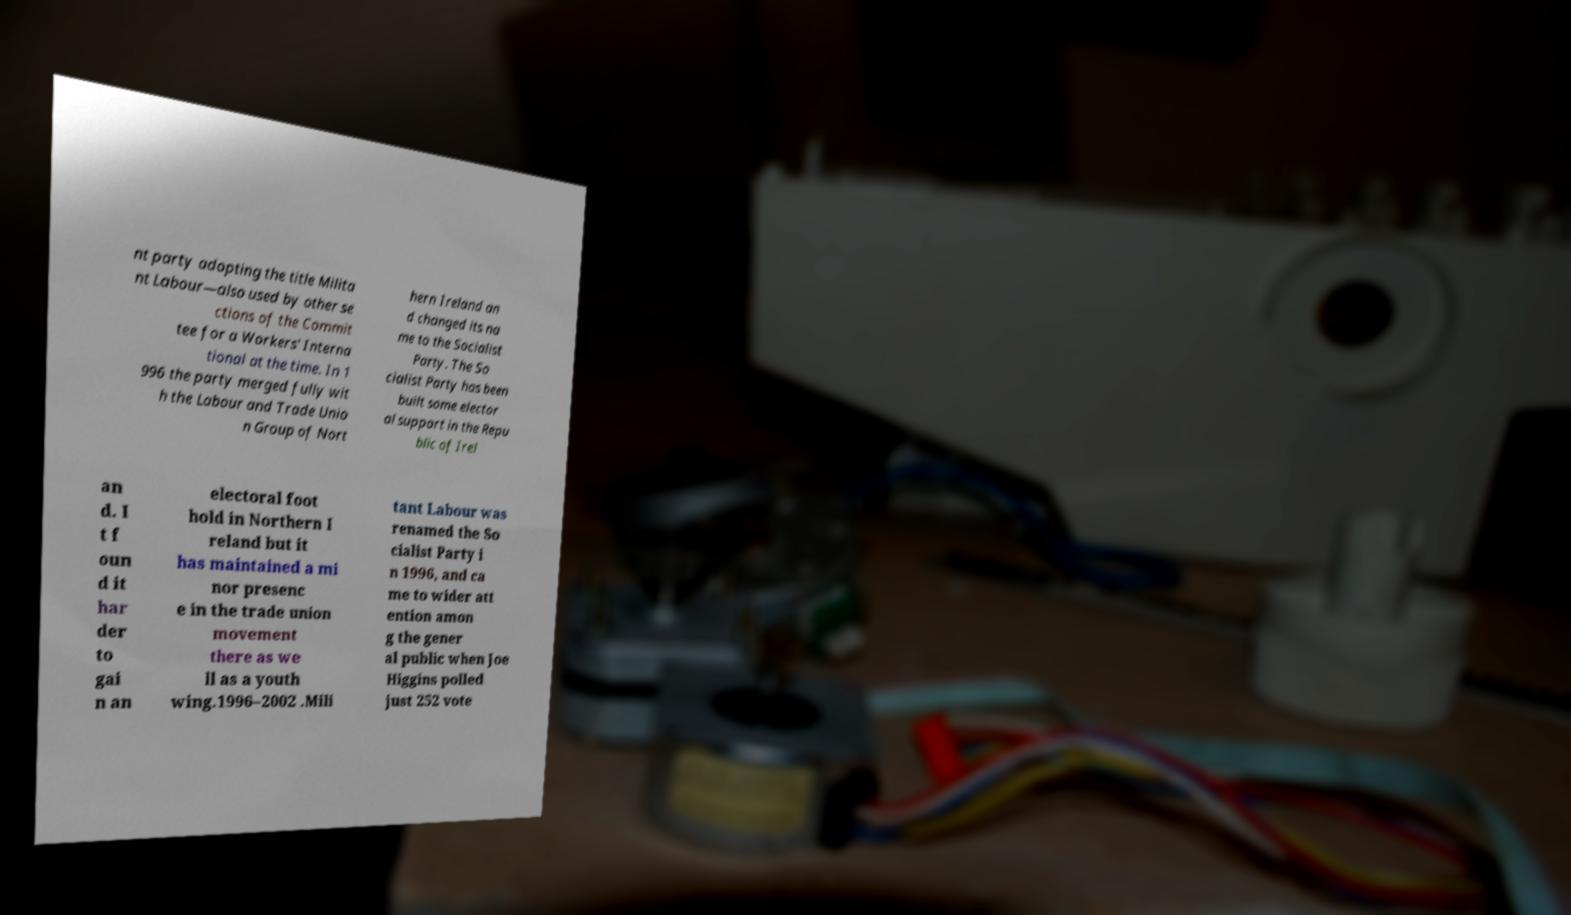I need the written content from this picture converted into text. Can you do that? nt party adopting the title Milita nt Labour—also used by other se ctions of the Commit tee for a Workers' Interna tional at the time. In 1 996 the party merged fully wit h the Labour and Trade Unio n Group of Nort hern Ireland an d changed its na me to the Socialist Party. The So cialist Party has been built some elector al support in the Repu blic of Irel an d. I t f oun d it har der to gai n an electoral foot hold in Northern I reland but it has maintained a mi nor presenc e in the trade union movement there as we ll as a youth wing.1996–2002 .Mili tant Labour was renamed the So cialist Party i n 1996, and ca me to wider att ention amon g the gener al public when Joe Higgins polled just 252 vote 